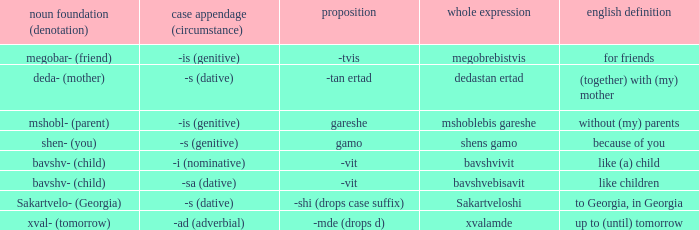What is Case Suffix (Case), when English Meaning is "to Georgia, in Georgia"? -s (dative). 